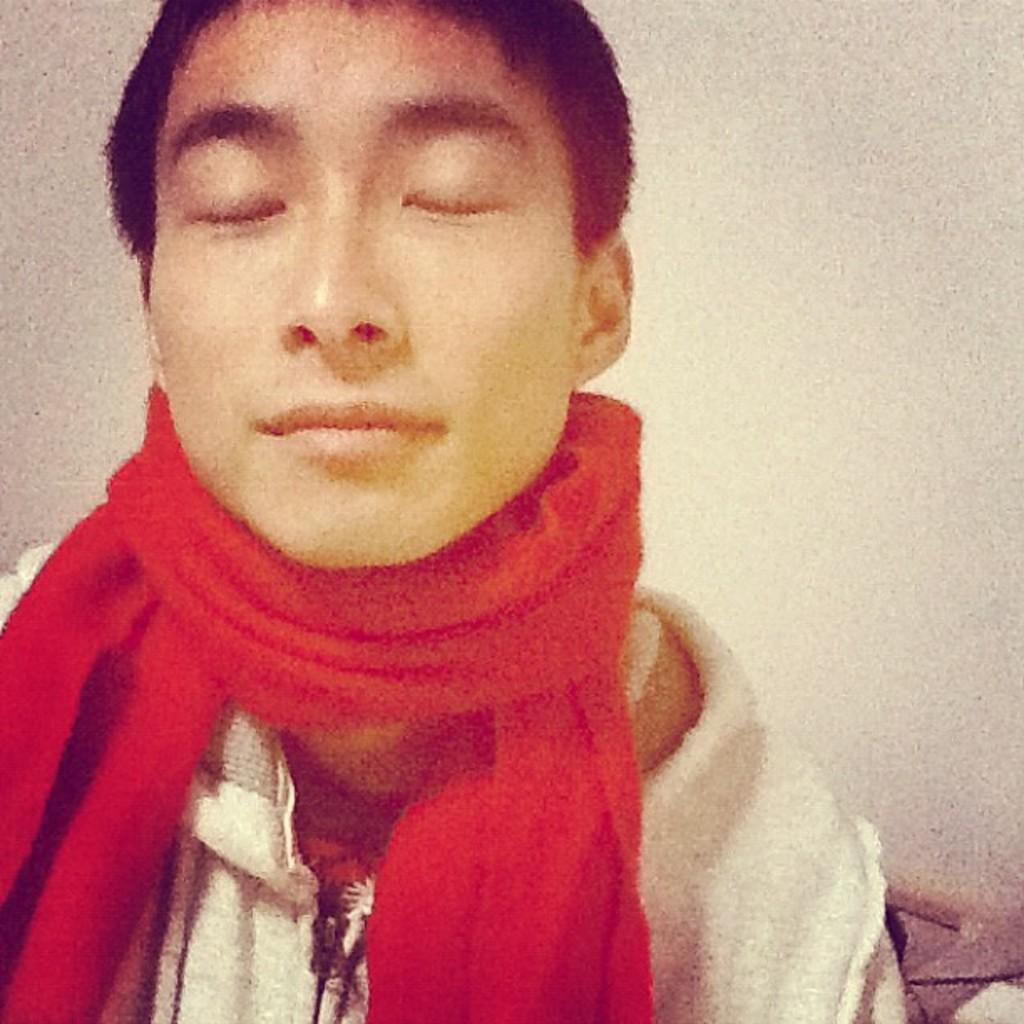What is present in the image? There is a person in the image. Can you describe the person's attire? The person is wearing a red scarf. What type of engine is visible in the image? There is no engine present in the image; it features a person wearing a red scarf. 